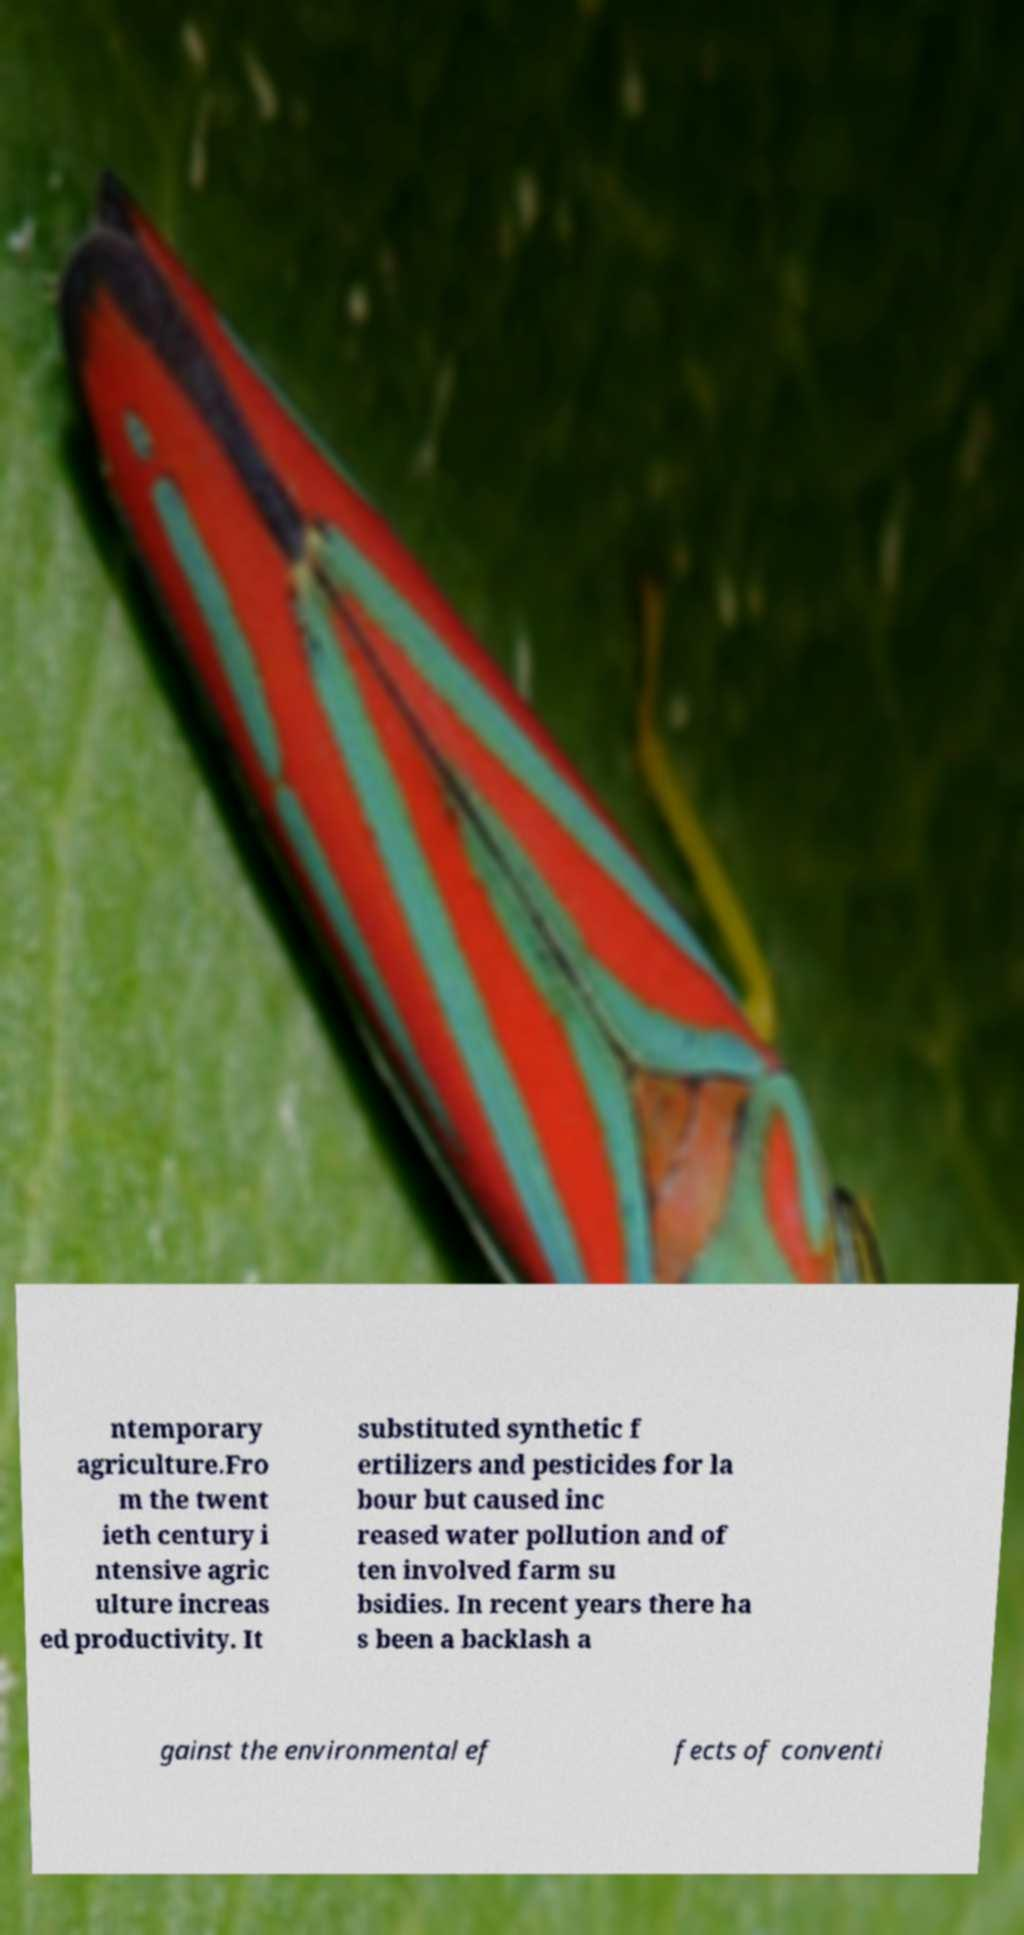Can you read and provide the text displayed in the image?This photo seems to have some interesting text. Can you extract and type it out for me? ntemporary agriculture.Fro m the twent ieth century i ntensive agric ulture increas ed productivity. It substituted synthetic f ertilizers and pesticides for la bour but caused inc reased water pollution and of ten involved farm su bsidies. In recent years there ha s been a backlash a gainst the environmental ef fects of conventi 